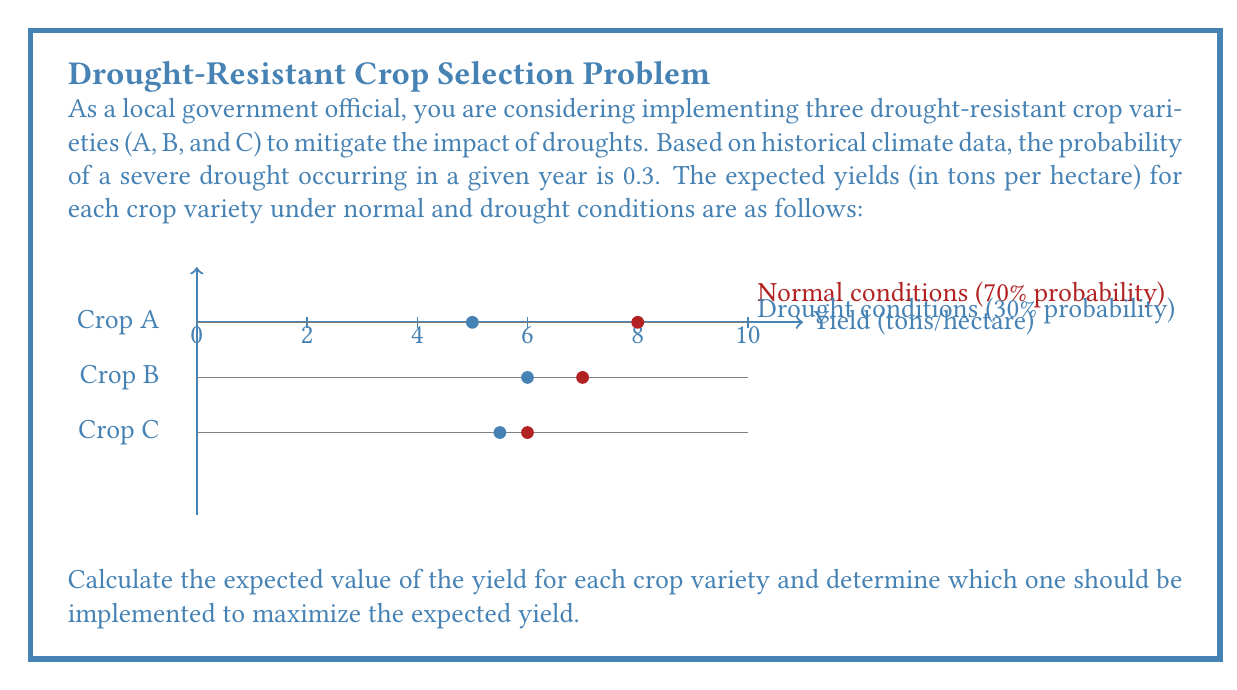Provide a solution to this math problem. To solve this problem, we need to calculate the expected value of the yield for each crop variety using the given probabilities and yields. Then, we'll compare the results to determine which variety maximizes the expected yield.

The formula for expected value is:

$$E(X) = \sum_{i=1}^{n} p_i \cdot x_i$$

Where $p_i$ is the probability of each outcome and $x_i$ is the value of each outcome.

For each crop variety:

1. Crop A:
   $$E(A) = 0.7 \cdot 8 + 0.3 \cdot 5 = 5.6 + 1.5 = 7.1 \text{ tons/hectare}$$

2. Crop B:
   $$E(B) = 0.7 \cdot 7 + 0.3 \cdot 6 = 4.9 + 1.8 = 6.7 \text{ tons/hectare}$$

3. Crop C:
   $$E(C) = 0.7 \cdot 6 + 0.3 \cdot 5.5 = 4.2 + 1.65 = 5.85 \text{ tons/hectare}$$

Comparing the expected values:
$E(A) = 7.1 > E(B) = 6.7 > E(C) = 5.85$

Therefore, Crop A has the highest expected yield and should be implemented to maximize the expected yield.
Answer: Crop A: 7.1 tons/hectare 